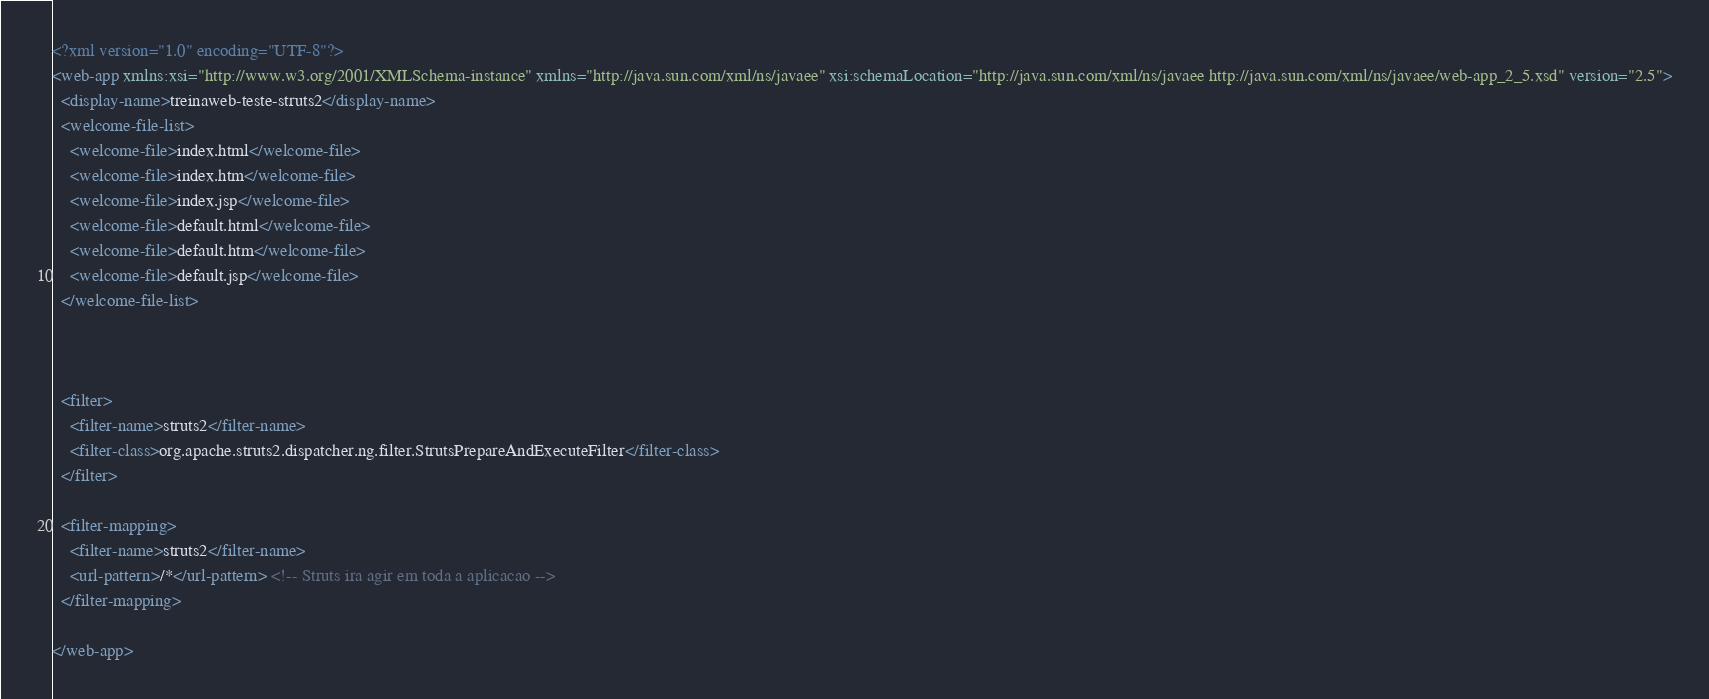<code> <loc_0><loc_0><loc_500><loc_500><_XML_><?xml version="1.0" encoding="UTF-8"?>
<web-app xmlns:xsi="http://www.w3.org/2001/XMLSchema-instance" xmlns="http://java.sun.com/xml/ns/javaee" xsi:schemaLocation="http://java.sun.com/xml/ns/javaee http://java.sun.com/xml/ns/javaee/web-app_2_5.xsd" version="2.5">
  <display-name>treinaweb-teste-struts2</display-name>
  <welcome-file-list>
    <welcome-file>index.html</welcome-file>
    <welcome-file>index.htm</welcome-file>
    <welcome-file>index.jsp</welcome-file>
    <welcome-file>default.html</welcome-file>
    <welcome-file>default.htm</welcome-file>
    <welcome-file>default.jsp</welcome-file>
  </welcome-file-list>
  
  
  
  <filter>
  	<filter-name>struts2</filter-name>
  	<filter-class>org.apache.struts2.dispatcher.ng.filter.StrutsPrepareAndExecuteFilter</filter-class>
  </filter>
  
  <filter-mapping>
  	<filter-name>struts2</filter-name>
  	<url-pattern>/*</url-pattern> <!-- Struts ira agir em toda a aplicacao -->
  </filter-mapping>
  
</web-app></code> 